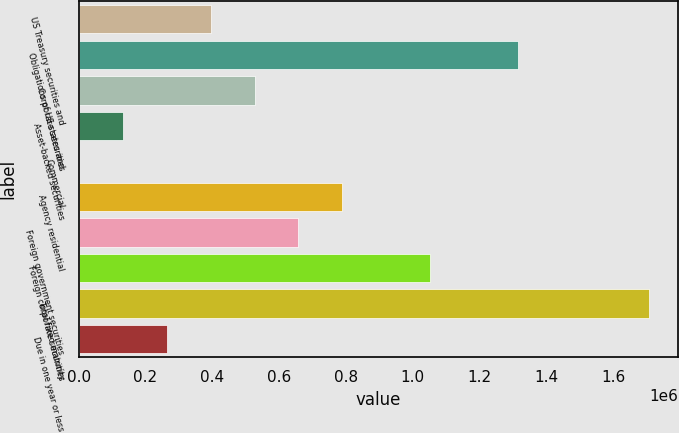<chart> <loc_0><loc_0><loc_500><loc_500><bar_chart><fcel>US Treasury securities and<fcel>Obligations of US states and<fcel>Corporate securities<fcel>Asset-backed securities<fcel>Commercial<fcel>Agency residential<fcel>Foreign government securities<fcel>Foreign corporate securities<fcel>Total fixed maturity<fcel>Due in one year or less<nl><fcel>395192<fcel>1.31506e+06<fcel>526602<fcel>132372<fcel>962<fcel>789421<fcel>658012<fcel>1.05224e+06<fcel>1.70929e+06<fcel>263782<nl></chart> 